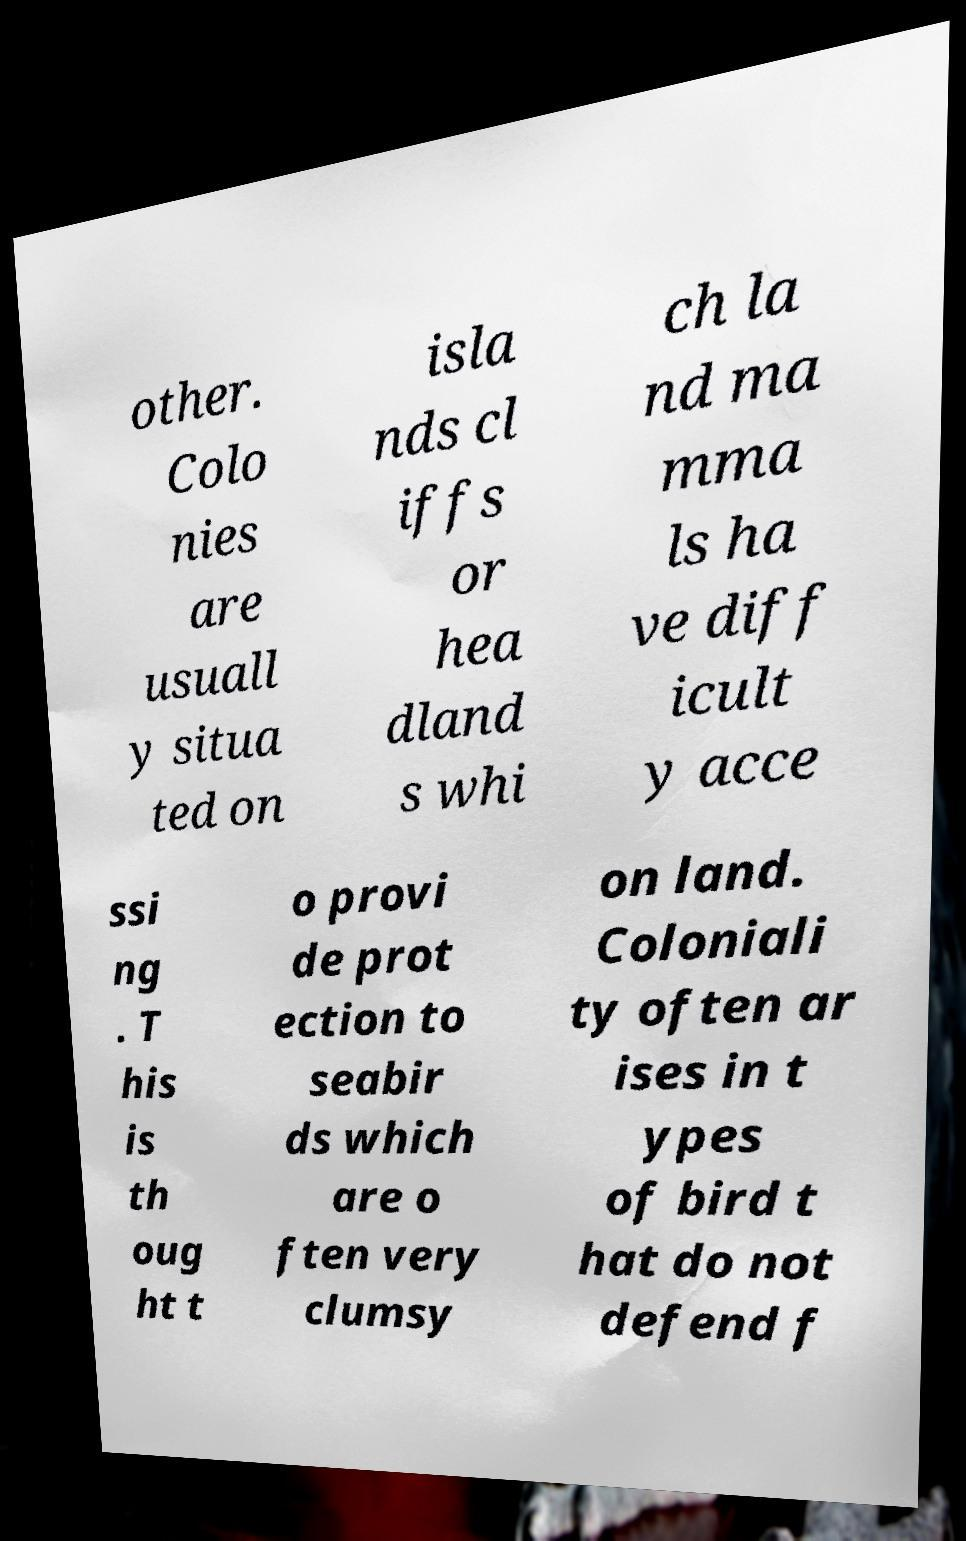I need the written content from this picture converted into text. Can you do that? other. Colo nies are usuall y situa ted on isla nds cl iffs or hea dland s whi ch la nd ma mma ls ha ve diff icult y acce ssi ng . T his is th oug ht t o provi de prot ection to seabir ds which are o ften very clumsy on land. Coloniali ty often ar ises in t ypes of bird t hat do not defend f 